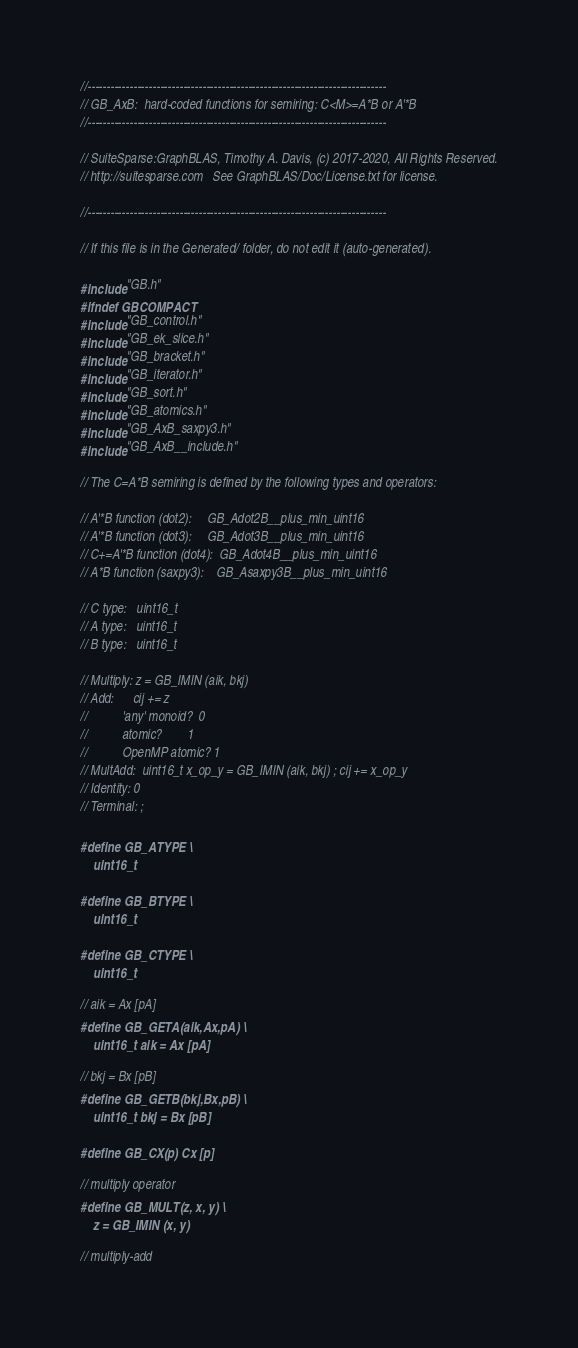Convert code to text. <code><loc_0><loc_0><loc_500><loc_500><_C_>//------------------------------------------------------------------------------
// GB_AxB:  hard-coded functions for semiring: C<M>=A*B or A'*B
//------------------------------------------------------------------------------

// SuiteSparse:GraphBLAS, Timothy A. Davis, (c) 2017-2020, All Rights Reserved.
// http://suitesparse.com   See GraphBLAS/Doc/License.txt for license.

//------------------------------------------------------------------------------

// If this file is in the Generated/ folder, do not edit it (auto-generated).

#include "GB.h"
#ifndef GBCOMPACT
#include "GB_control.h"
#include "GB_ek_slice.h"
#include "GB_bracket.h"
#include "GB_iterator.h"
#include "GB_sort.h"
#include "GB_atomics.h"
#include "GB_AxB_saxpy3.h"
#include "GB_AxB__include.h"

// The C=A*B semiring is defined by the following types and operators:

// A'*B function (dot2):     GB_Adot2B__plus_min_uint16
// A'*B function (dot3):     GB_Adot3B__plus_min_uint16
// C+=A'*B function (dot4):  GB_Adot4B__plus_min_uint16
// A*B function (saxpy3):    GB_Asaxpy3B__plus_min_uint16

// C type:   uint16_t
// A type:   uint16_t
// B type:   uint16_t

// Multiply: z = GB_IMIN (aik, bkj)
// Add:      cij += z
//           'any' monoid?  0
//           atomic?        1
//           OpenMP atomic? 1
// MultAdd:  uint16_t x_op_y = GB_IMIN (aik, bkj) ; cij += x_op_y
// Identity: 0
// Terminal: ;

#define GB_ATYPE \
    uint16_t

#define GB_BTYPE \
    uint16_t

#define GB_CTYPE \
    uint16_t

// aik = Ax [pA]
#define GB_GETA(aik,Ax,pA) \
    uint16_t aik = Ax [pA]

// bkj = Bx [pB]
#define GB_GETB(bkj,Bx,pB) \
    uint16_t bkj = Bx [pB]

#define GB_CX(p) Cx [p]

// multiply operator
#define GB_MULT(z, x, y) \
    z = GB_IMIN (x, y)

// multiply-add</code> 